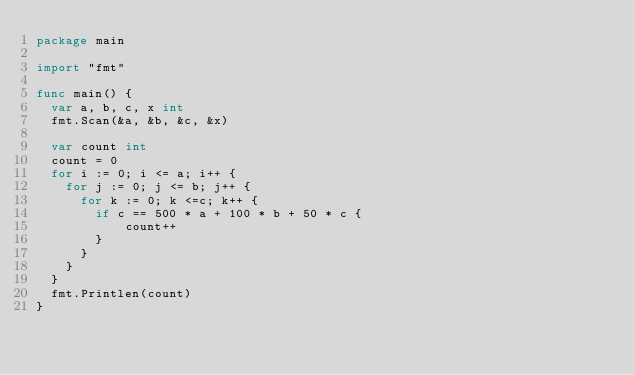Convert code to text. <code><loc_0><loc_0><loc_500><loc_500><_Go_>package main

import "fmt"

func main() {
  var a, b, c, x int
  fmt.Scan(&a, &b, &c, &x)
  
  var count int
  count = 0
  for i := 0; i <= a; i++ {
    for j := 0; j <= b; j++ {
      for k := 0; k <=c; k++ {
        if c == 500 * a + 100 * b + 50 * c {
        	count++
        }
      }
    }
  }
  fmt.Printlen(count)
}

</code> 